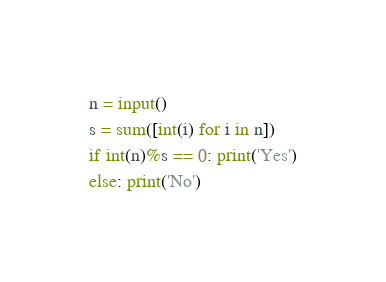Convert code to text. <code><loc_0><loc_0><loc_500><loc_500><_Python_>n = input()
s = sum([int(i) for i in n])
if int(n)%s == 0: print('Yes')
else: print('No')
</code> 